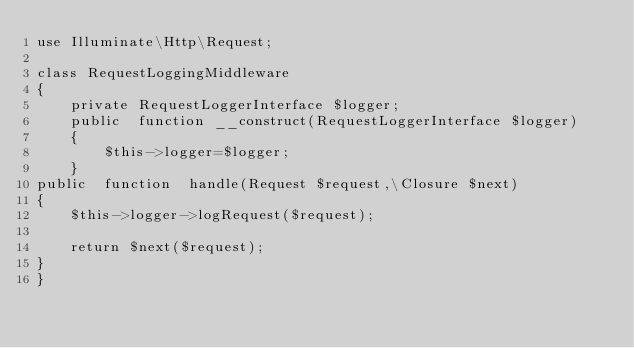<code> <loc_0><loc_0><loc_500><loc_500><_PHP_>use Illuminate\Http\Request;

class RequestLoggingMiddleware
{
    private RequestLoggerInterface $logger;
    public  function __construct(RequestLoggerInterface $logger)
    {
        $this->logger=$logger;
    }
public  function  handle(Request $request,\Closure $next)
{
    $this->logger->logRequest($request);

    return $next($request);
}
}
</code> 